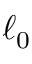Convert formula to latex. <formula><loc_0><loc_0><loc_500><loc_500>\ell _ { 0 }</formula> 